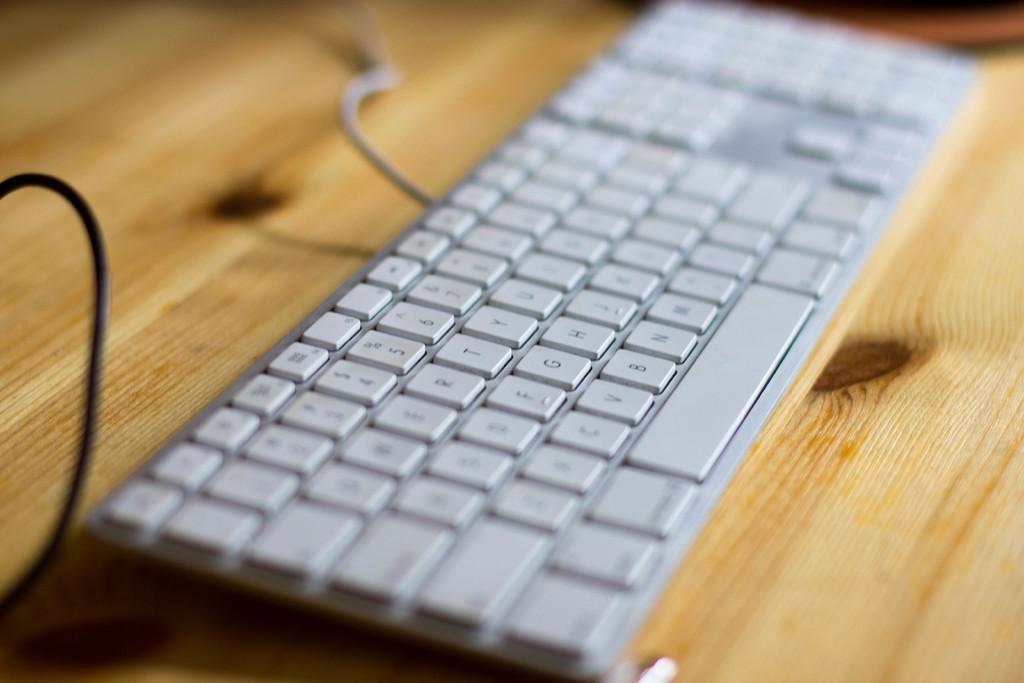Provide a one-sentence caption for the provided image. The keyboard B key is right next to the V key. 